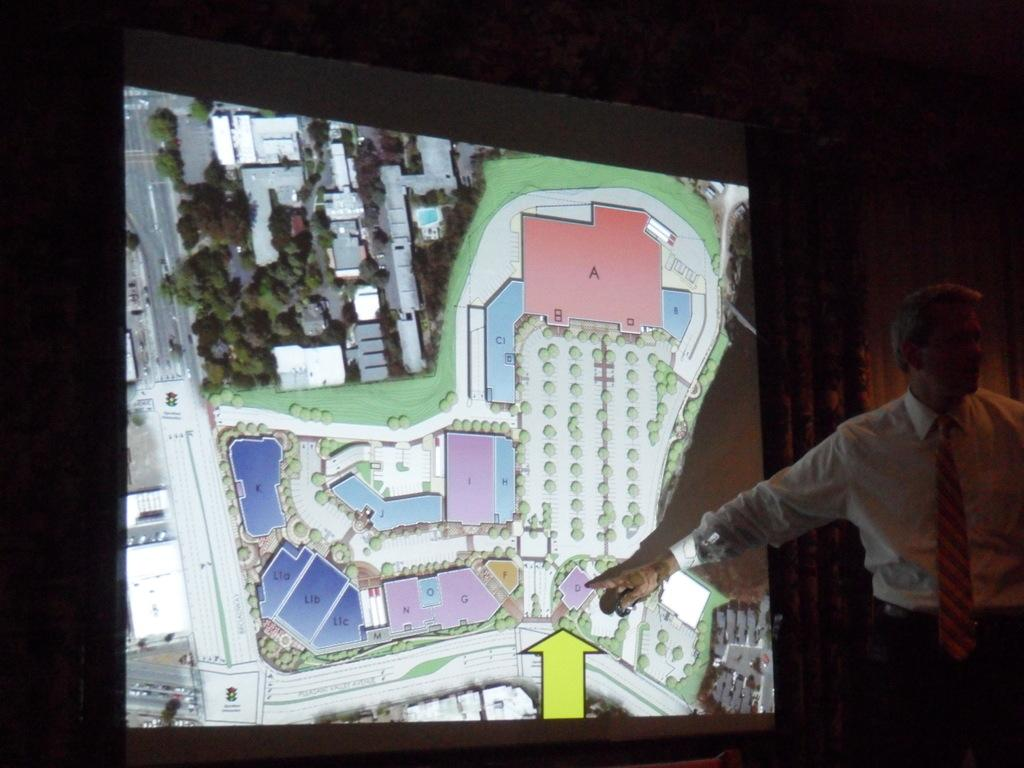Who is the main subject in the image? There is a man in the image. Where is the man located in the image? The man is standing on the right side of the image. What is the man doing in the image? The man is pointing to a screen. How would you describe the lighting in the image? The image is dark or has a dark area. What type of part is the man playing in the spy movie in the image? There is no indication of a spy movie or any spy-related activities in the image. 